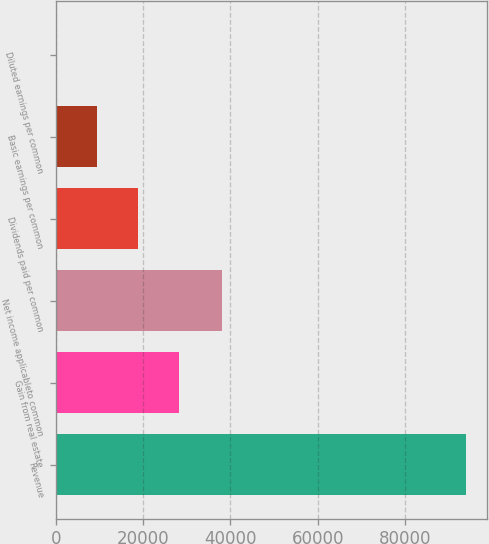Convert chart. <chart><loc_0><loc_0><loc_500><loc_500><bar_chart><fcel>Revenue<fcel>Gain from real estate<fcel>Net income applicableto common<fcel>Dividends paid per common<fcel>Basic earnings per common<fcel>Diluted earnings per common<nl><fcel>94091<fcel>28227.5<fcel>38175<fcel>18818.4<fcel>9409.35<fcel>0.28<nl></chart> 